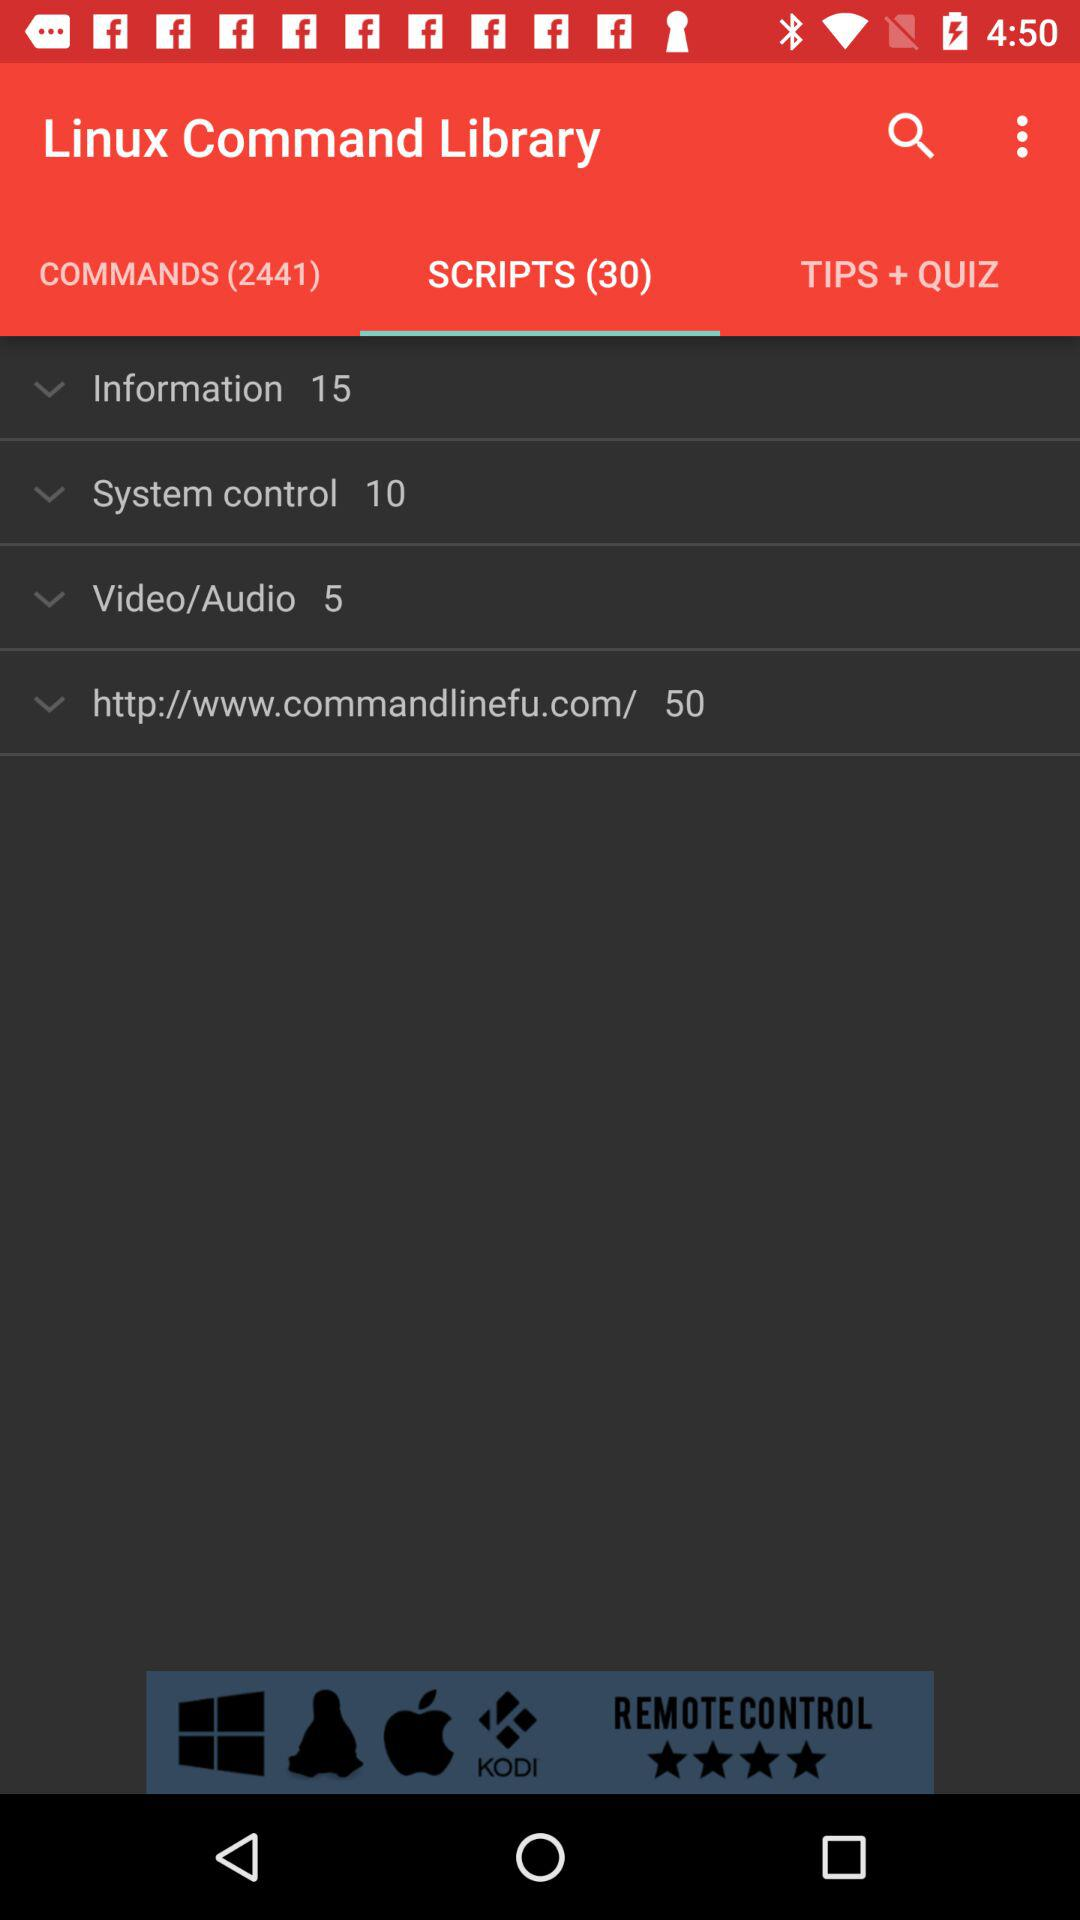Which tab has been selected? The selected tab is "SCRIPTS (30)". 